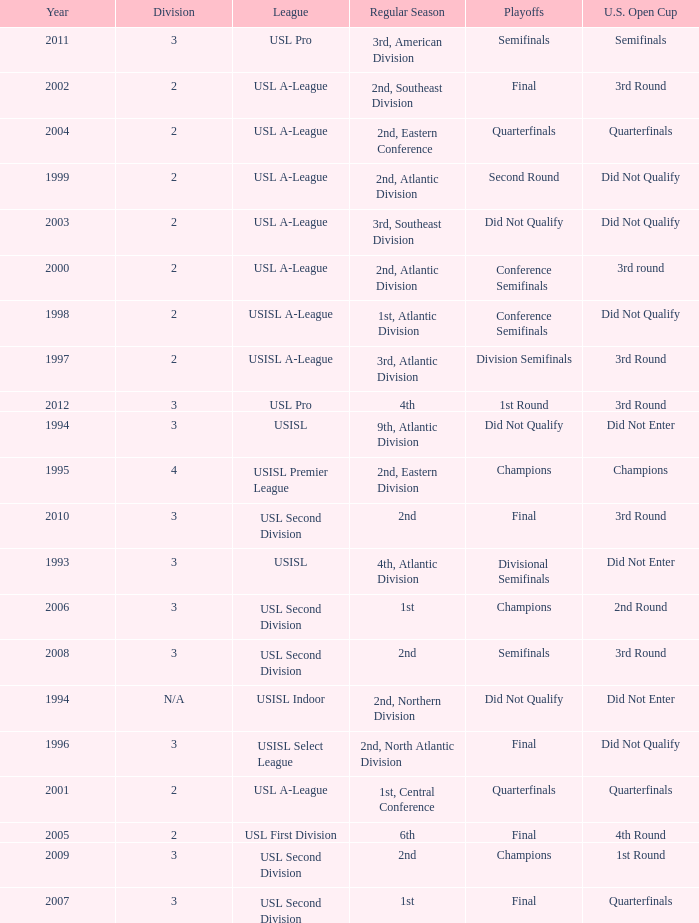Which round is u.s. open cup division semifinals 3rd Round. 